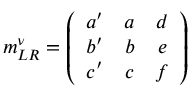<formula> <loc_0><loc_0><loc_500><loc_500>m _ { L R } ^ { \nu } = \left ( \begin{array} { c c c } { { a ^ { \prime } } } & { a } & { d } \\ { { b ^ { \prime } } } & { b } & { e } \\ { { c ^ { \prime } } } & { c } & { f } \end{array} \right )</formula> 